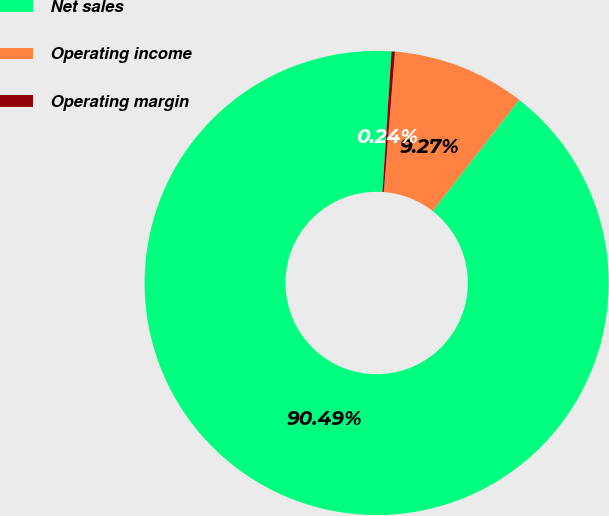Convert chart. <chart><loc_0><loc_0><loc_500><loc_500><pie_chart><fcel>Net sales<fcel>Operating income<fcel>Operating margin<nl><fcel>90.49%<fcel>9.27%<fcel>0.24%<nl></chart> 